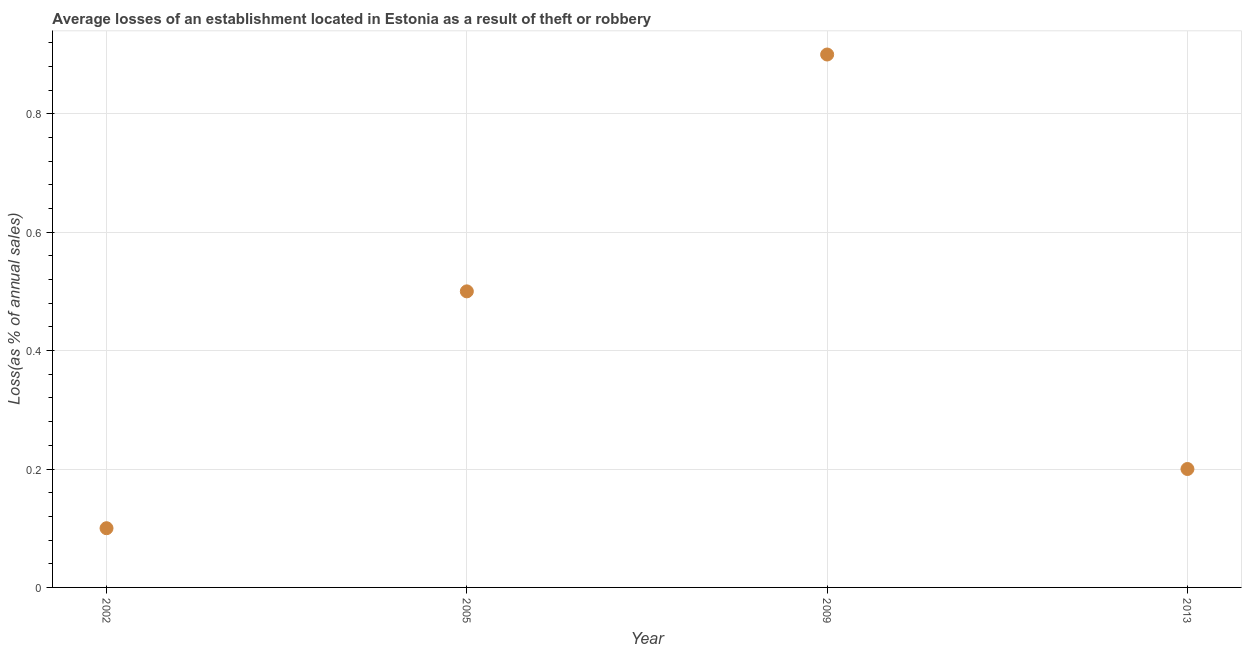In which year was the losses due to theft minimum?
Offer a terse response. 2002. What is the sum of the losses due to theft?
Your answer should be compact. 1.7. What is the difference between the losses due to theft in 2005 and 2009?
Offer a very short reply. -0.4. What is the average losses due to theft per year?
Make the answer very short. 0.42. In how many years, is the losses due to theft greater than 0.7600000000000001 %?
Offer a very short reply. 1. Do a majority of the years between 2009 and 2013 (inclusive) have losses due to theft greater than 0.52 %?
Provide a short and direct response. No. What is the ratio of the losses due to theft in 2002 to that in 2013?
Make the answer very short. 0.5. Is the losses due to theft in 2009 less than that in 2013?
Keep it short and to the point. No. Is the difference between the losses due to theft in 2002 and 2005 greater than the difference between any two years?
Make the answer very short. No. What is the difference between the highest and the second highest losses due to theft?
Ensure brevity in your answer.  0.4. Is the sum of the losses due to theft in 2005 and 2009 greater than the maximum losses due to theft across all years?
Give a very brief answer. Yes. Does the losses due to theft monotonically increase over the years?
Your answer should be very brief. No. How many dotlines are there?
Your response must be concise. 1. Are the values on the major ticks of Y-axis written in scientific E-notation?
Keep it short and to the point. No. Does the graph contain any zero values?
Provide a short and direct response. No. Does the graph contain grids?
Your response must be concise. Yes. What is the title of the graph?
Keep it short and to the point. Average losses of an establishment located in Estonia as a result of theft or robbery. What is the label or title of the X-axis?
Your answer should be compact. Year. What is the label or title of the Y-axis?
Offer a very short reply. Loss(as % of annual sales). What is the Loss(as % of annual sales) in 2005?
Provide a succinct answer. 0.5. What is the Loss(as % of annual sales) in 2013?
Your response must be concise. 0.2. What is the difference between the Loss(as % of annual sales) in 2002 and 2009?
Keep it short and to the point. -0.8. What is the difference between the Loss(as % of annual sales) in 2002 and 2013?
Offer a terse response. -0.1. What is the difference between the Loss(as % of annual sales) in 2005 and 2013?
Offer a very short reply. 0.3. What is the ratio of the Loss(as % of annual sales) in 2002 to that in 2009?
Make the answer very short. 0.11. What is the ratio of the Loss(as % of annual sales) in 2002 to that in 2013?
Your answer should be very brief. 0.5. What is the ratio of the Loss(as % of annual sales) in 2005 to that in 2009?
Ensure brevity in your answer.  0.56. What is the ratio of the Loss(as % of annual sales) in 2005 to that in 2013?
Your response must be concise. 2.5. 